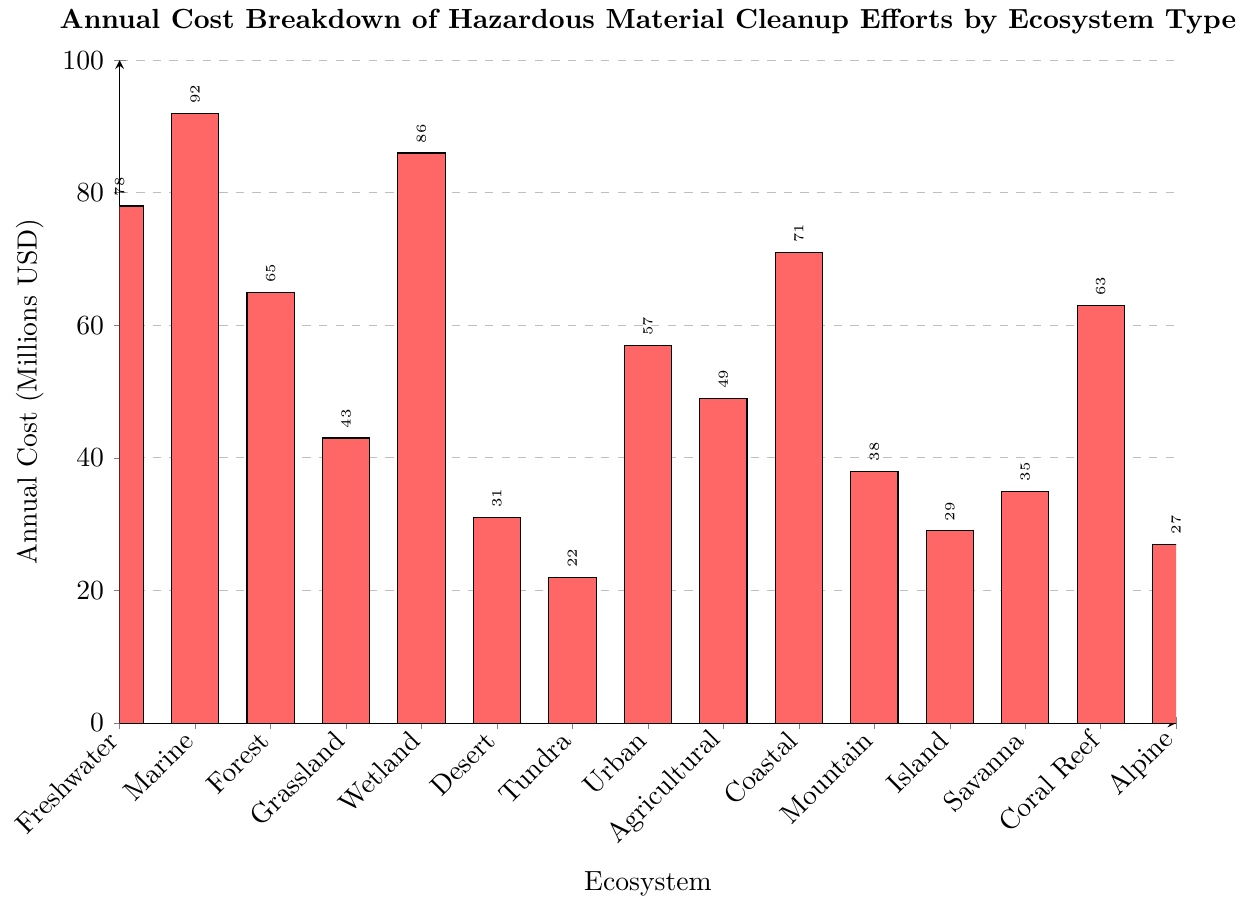What ecosystem type has the highest annual cost for hazardous material cleanup? By examining the height of the bars, the Marine ecosystem has the highest bar, indicating it has the highest annual cleanup cost of 92 million USD.
Answer: Marine What ecosystem type has the lowest annual cost for hazardous material cleanup? By looking at the shortest bar, the Tundra ecosystem has the lowest annual cleanup cost at 22 million USD.
Answer: Tundra How much more is spent on hazardous material cleanup in Marine ecosystems compared to Desert ecosystems? The cost for Marine ecosystems is 92 million USD, and for Desert ecosystems, it is 31 million USD. The difference is 92 - 31 = 61 million USD.
Answer: 61 million USD What is the combined annual cost for hazardous material cleanup in Wetland and Coastal ecosystems? Adding the costs for Wetland (86 million USD) and Coastal (71 million USD) ecosystems gives 86 + 71 = 157 million USD.
Answer: 157 million USD Which ecosystems have an annual cleanup cost greater than 60 million USD? By identifying bars higher than 60 on the y-axis, the ecosystems are Marine (92), Freshwater (78), Wetland (86), Coral Reef (63), and Coastal (71).
Answer: Marine, Freshwater, Wetland, Coral Reef, Coastal What is the annual cleanup cost difference between Urban and Agricultural ecosystems? The cost for Urban ecosystems is 57 million USD and for Agricultural ecosystems, it is 49 million USD. The difference is 57 - 49 = 8 million USD.
Answer: 8 million USD What is the median annual cost among the listed ecosystems? To find the median, list the costs in ascending order: 22, 27, 29, 31, 35, 38, 43, 49, 57, 63, 65, 71, 78, 86, 92. The median of these 15 values is the 8th value, which is 49 million USD.
Answer: 49 million USD What is the average (mean) annual cost for hazardous material cleanup across all ecosystems? Sum the costs: 78 + 92 + 65 + 43 + 86 + 31 + 22 + 57 + 49 + 71 + 38 + 29 + 35 + 63 + 27 = 786. Divide by the number of ecosystems (15): 786 / 15 = 52.4 million USD.
Answer: 52.4 million USD Which ecosystem has a cleanup cost closest to the average annual cleanup cost? The average cost is 52.4 million USD. The closest values are for Urban (57 million USD) and Agricultural (49 million USD). Urban is 4.6 million USD away, and Agricultural is 3.4 million USD away. Therefore, Agricultural is closest.
Answer: Agricultural Among the ecosystems with less than 50 million USD in annual cleanup costs, which one has the highest cost? Identify ecosystems with costs less than 50 million USD: Grassland (43), Desert (31), Tundra (22), Mountain (38), Island (29), Savanna (35), Alpine (27). The highest cost among these is Grassland at 43 million USD.
Answer: Grassland 